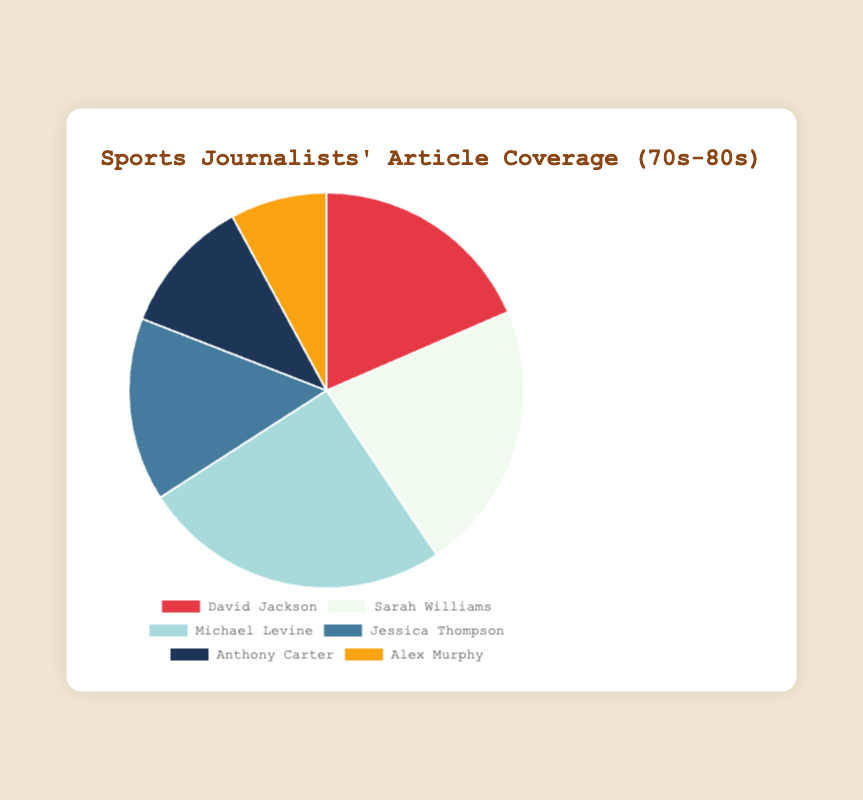Which journalist had the highest percentage of articles covered? Michael Levine had the highest percentage as indicated by his 25.3% share of the pie chart, clearly the largest segment
Answer: Michael Levine Which two journalists together covered more than 40% of the articles? The top two journalists, Michael Levine and Sarah Williams, have percentages of 25.3% and 22.1%, respectively. Adding these gives 25.3 + 22.1 = 47.4%, which is more than 40%
Answer: Michael Levine and Sarah Williams How much larger is Sarah Williams' percentage of articles covered compared to Jessica Thompson's? Sarah Williams has 22.1%, and Jessica Thompson has 15.0%. The difference is 22.1 - 15.0 = 7.1%
Answer: 7.1% Which journalist had the smallest percentage of articles covered? The smallest percentage, represented by the smallest segment of the pie chart, belongs to Alex Murphy at 7.9%
Answer: Alex Murphy What are the combined percentages of articles covered by David Jackson and Anthony Carter? David Jackson has 18.5%, and Anthony Carter has 11.2%. Summing these gives 18.5 + 11.2 = 29.7%
Answer: 29.7% Whose article coverage is closest to the average percentage of all journalists'? The overall percentages are 18.5, 22.1, 25.3, 15.0, 11.2, and 7.9. Summing these gives 100%, and dividing by 6 journalists, the average is 100 / 6 ≈ 16.67%. Jessica Thompson, at 15.0%, is closest to this average
Answer: Jessica Thompson What is the percentage difference between the journalist with the highest coverage and the one with the lowest? Michael Levine has the highest at 25.3%, and Alex Murphy has the lowest at 7.9%. The difference is 25.3 - 7.9 = 17.4%
Answer: 17.4% Arrange the journalists in ascending order of their article coverage percentages. Looking at the data, the percentages are: Alex Murphy (7.9%), Anthony Carter (11.2%), Jessica Thompson (15.0%), David Jackson (18.5%), Sarah Williams (22.1%), Michael Levine (25.3%)
Answer: Alex Murphy, Anthony Carter, Jessica Thompson, David Jackson, Sarah Williams, Michael Levine 